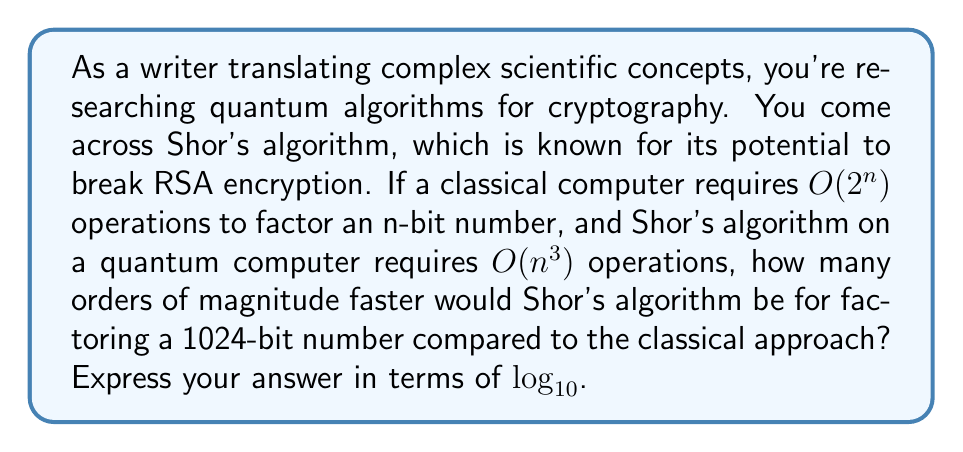Can you solve this math problem? To solve this problem, we need to compare the time complexity of classical factoring algorithms with Shor's quantum algorithm for a 1024-bit number. Let's break it down step-by-step:

1) For a classical computer:
   Time complexity = $O(2^n)$
   For n = 1024, this becomes $O(2^{1024})$

2) For Shor's algorithm on a quantum computer:
   Time complexity = $O(n^3)$
   For n = 1024, this becomes $O(1024^3) = O(1,073,741,824)$

3) To compare these, we need to calculate the ratio:
   $\frac{2^{1024}}{1024^3}$

4) To simplify this calculation, we can use logarithms:
   $\log_{10}(2^{1024}) - \log_{10}(1024^3)$

5) Simplify further:
   $1024 \cdot \log_{10}(2) - 3 \cdot \log_{10}(1024)$

6) Calculate:
   $1024 \cdot 0.301 - 3 \cdot 3.01 \approx 308.224 - 9.03 \approx 299.194$

7) This result represents the number of orders of magnitude difference between the two algorithms.
Answer: Shor's algorithm would be approximately $299.194$ orders of magnitude faster than the classical approach for factoring a 1024-bit number. 